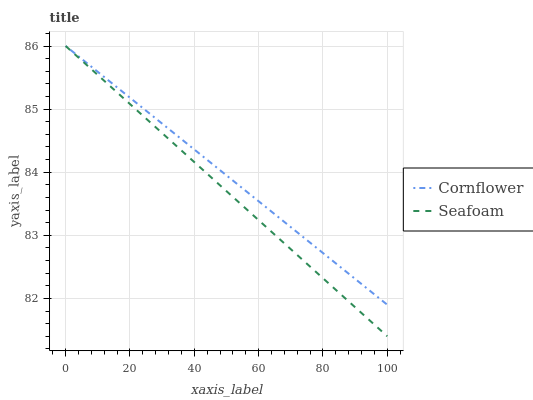Does Seafoam have the minimum area under the curve?
Answer yes or no. Yes. Does Cornflower have the maximum area under the curve?
Answer yes or no. Yes. Does Seafoam have the maximum area under the curve?
Answer yes or no. No. Is Cornflower the smoothest?
Answer yes or no. Yes. Is Seafoam the roughest?
Answer yes or no. Yes. Is Seafoam the smoothest?
Answer yes or no. No. Does Seafoam have the lowest value?
Answer yes or no. Yes. Does Seafoam have the highest value?
Answer yes or no. Yes. Does Cornflower intersect Seafoam?
Answer yes or no. Yes. Is Cornflower less than Seafoam?
Answer yes or no. No. Is Cornflower greater than Seafoam?
Answer yes or no. No. 